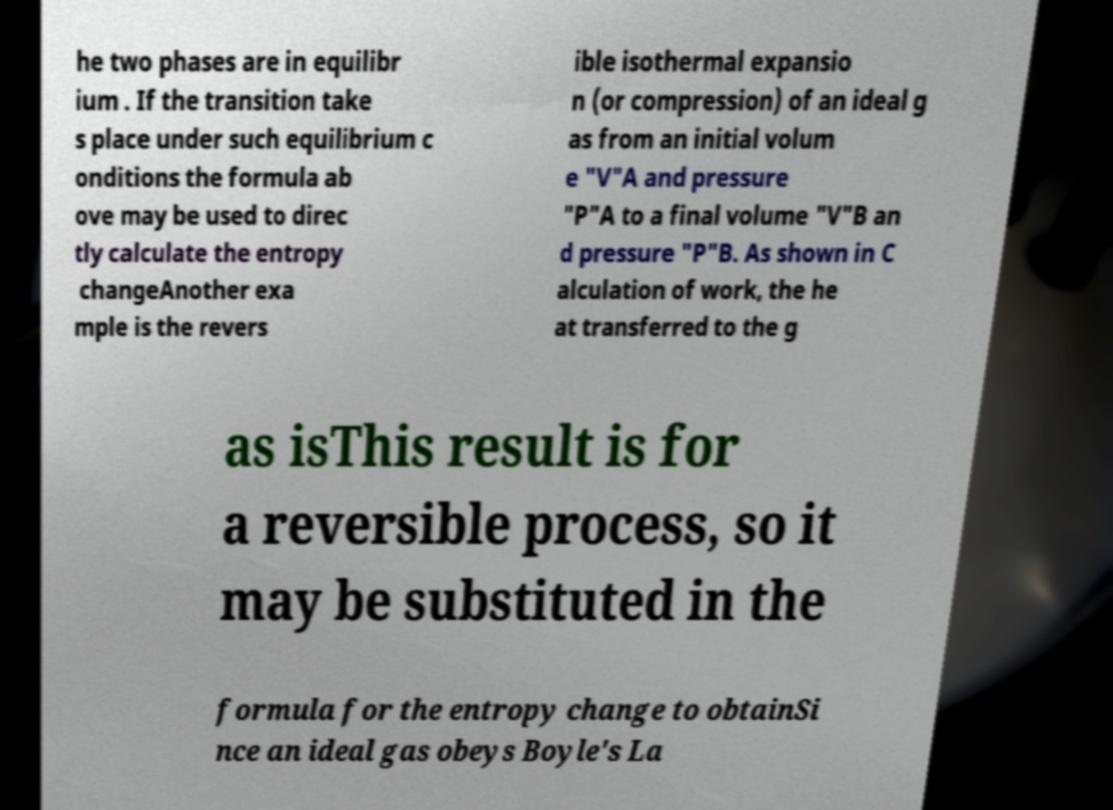Could you extract and type out the text from this image? he two phases are in equilibr ium . If the transition take s place under such equilibrium c onditions the formula ab ove may be used to direc tly calculate the entropy changeAnother exa mple is the revers ible isothermal expansio n (or compression) of an ideal g as from an initial volum e "V"A and pressure "P"A to a final volume "V"B an d pressure "P"B. As shown in C alculation of work, the he at transferred to the g as isThis result is for a reversible process, so it may be substituted in the formula for the entropy change to obtainSi nce an ideal gas obeys Boyle's La 